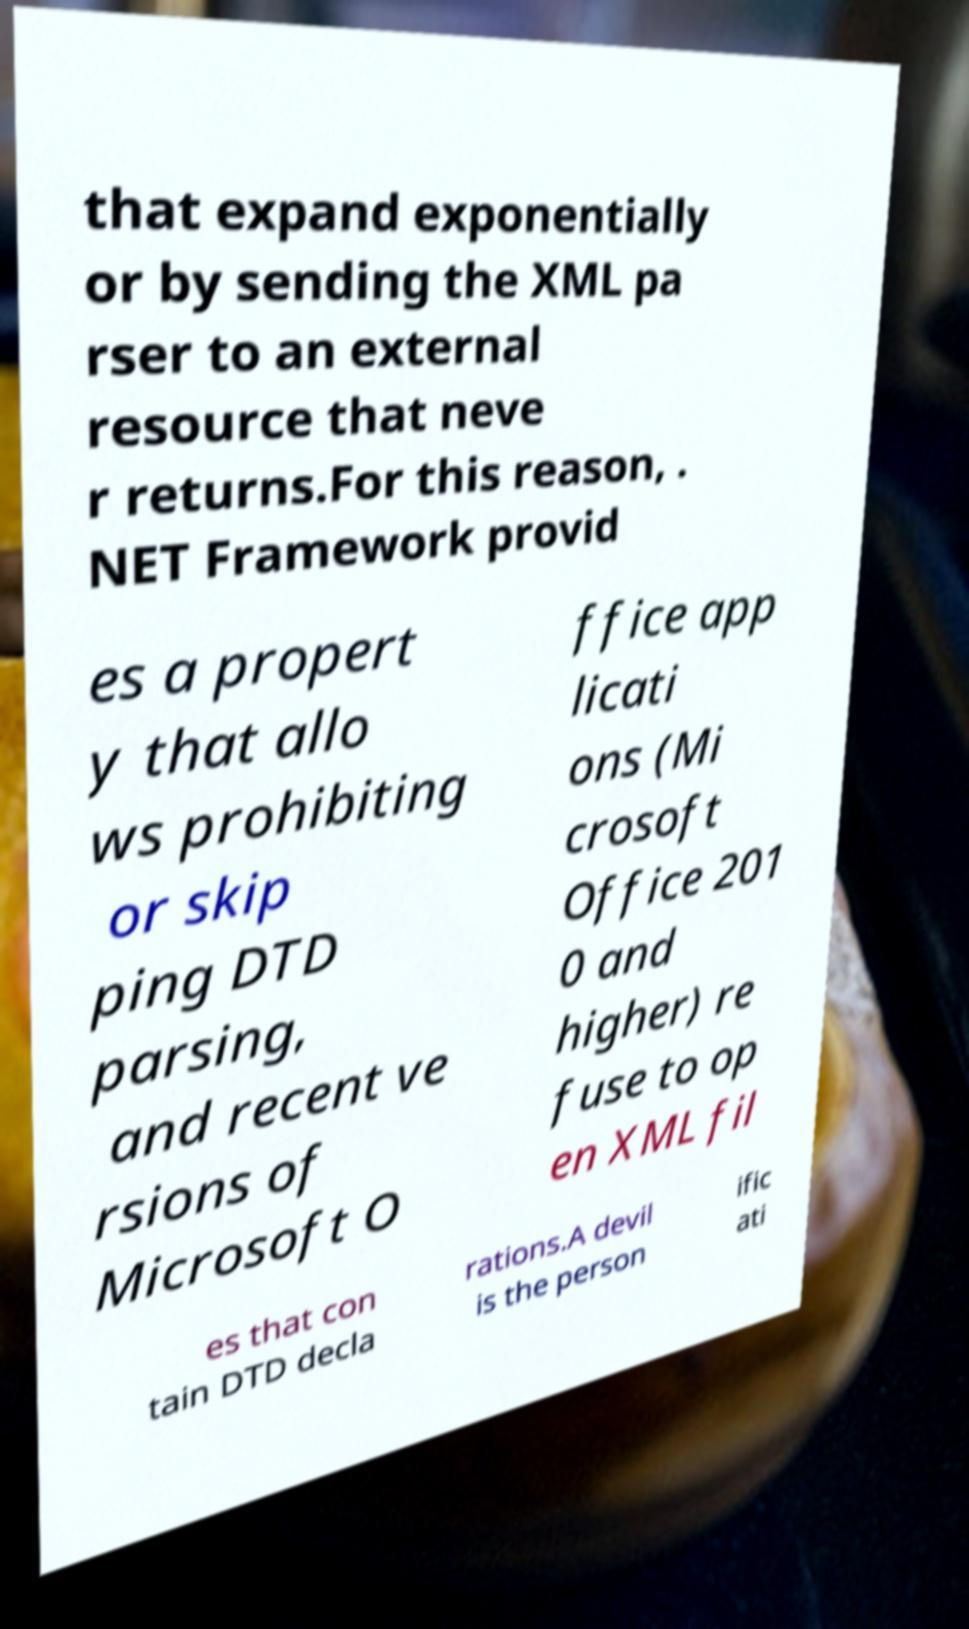Could you extract and type out the text from this image? that expand exponentially or by sending the XML pa rser to an external resource that neve r returns.For this reason, . NET Framework provid es a propert y that allo ws prohibiting or skip ping DTD parsing, and recent ve rsions of Microsoft O ffice app licati ons (Mi crosoft Office 201 0 and higher) re fuse to op en XML fil es that con tain DTD decla rations.A devil is the person ific ati 